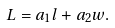<formula> <loc_0><loc_0><loc_500><loc_500>L = a _ { 1 } l + a _ { 2 } w .</formula> 